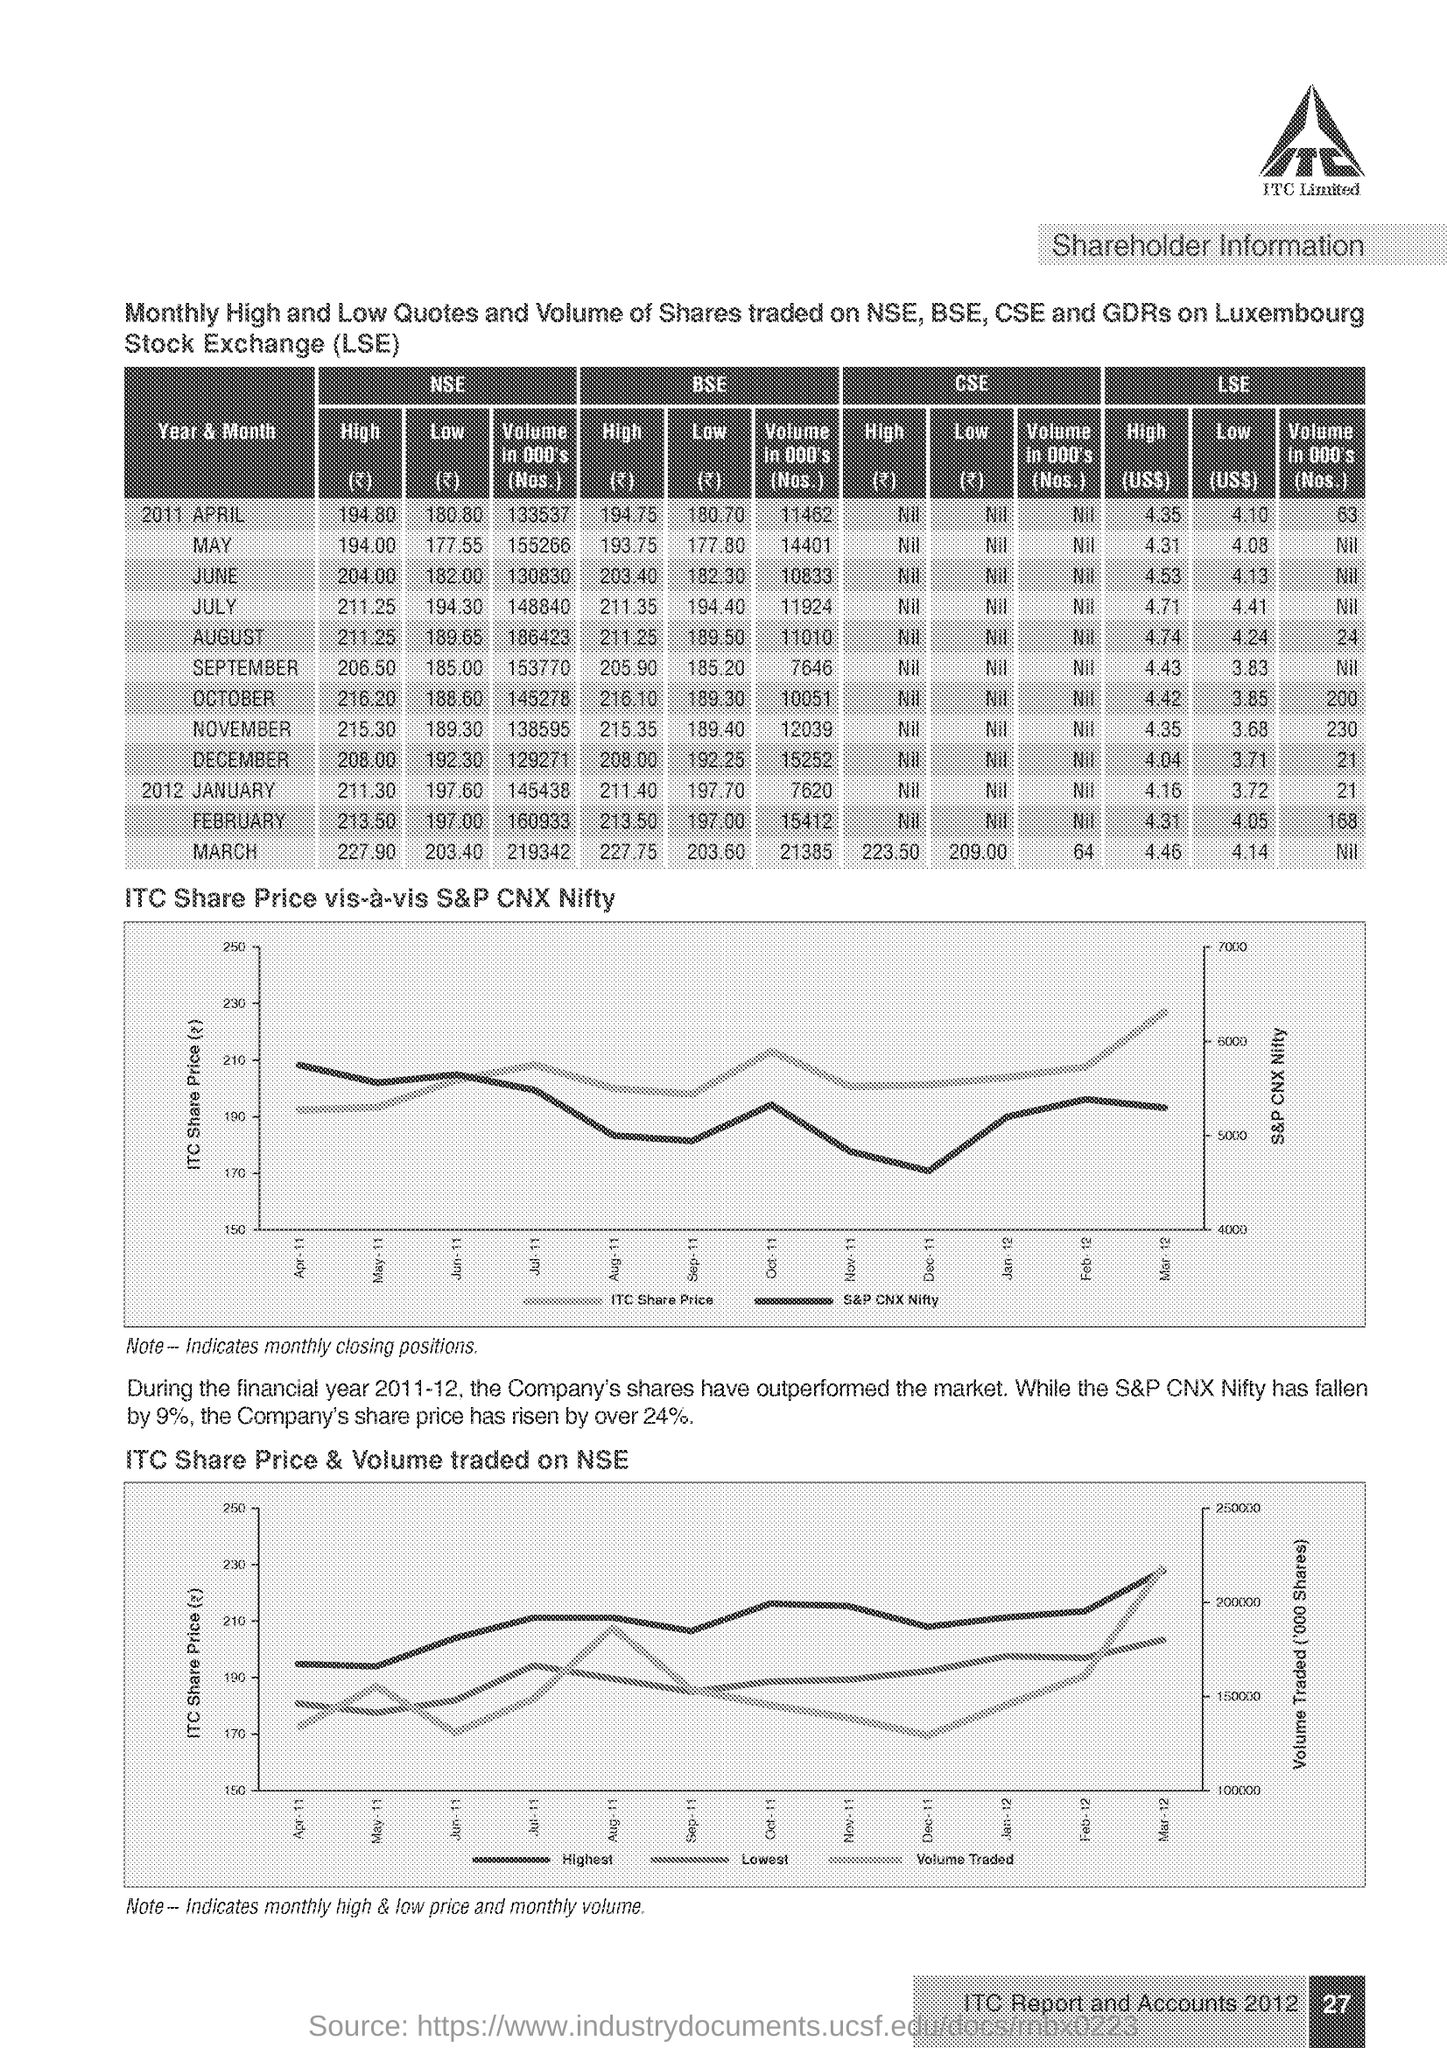Point out several critical features in this image. The left side of the Y-axis in the "ITC Share Price vis-a-vis S&P CNX Nifty" graph represents the ITC share price. The last graph displays the ITC share price and volume traded on the NSE. In October 2011, the "LOW" quote for a share traded on the BSE was 189.30. The text within the logo is 'ITC.' Please mention the page number provided at the bottom right corner of the page, which is 27.. 